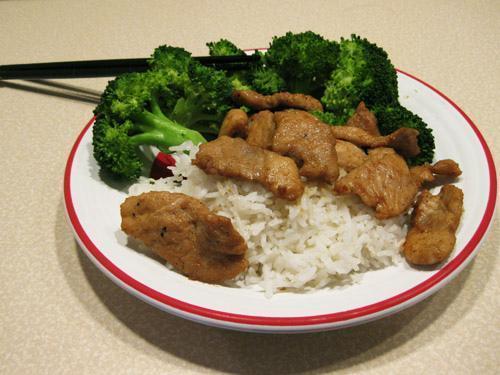How many broccolis are there?
Give a very brief answer. 3. 